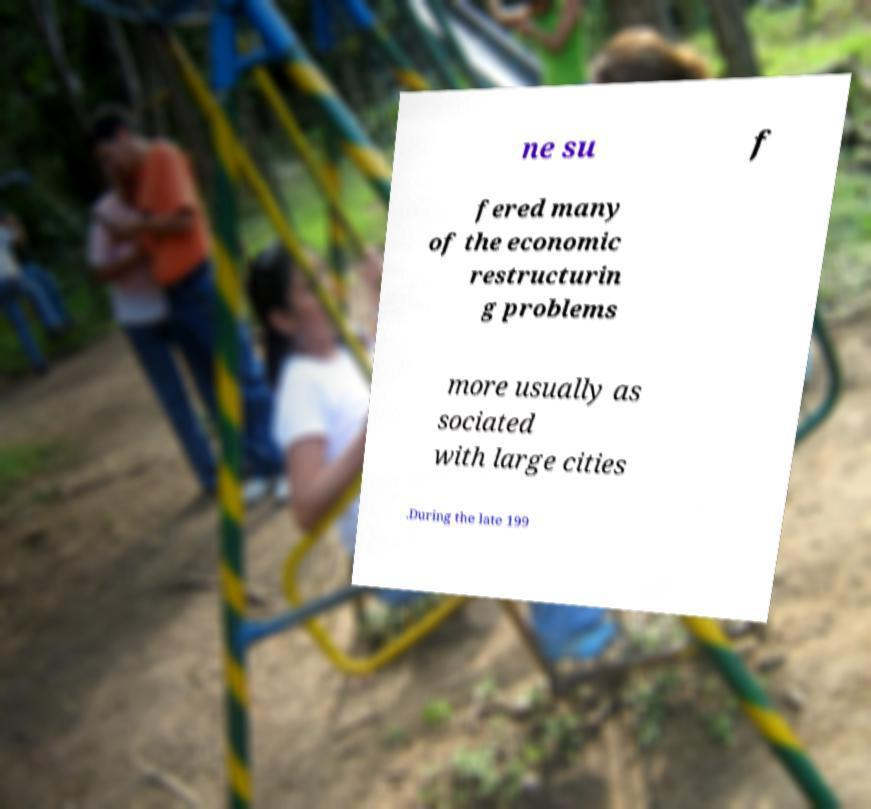Can you accurately transcribe the text from the provided image for me? ne su f fered many of the economic restructurin g problems more usually as sociated with large cities .During the late 199 